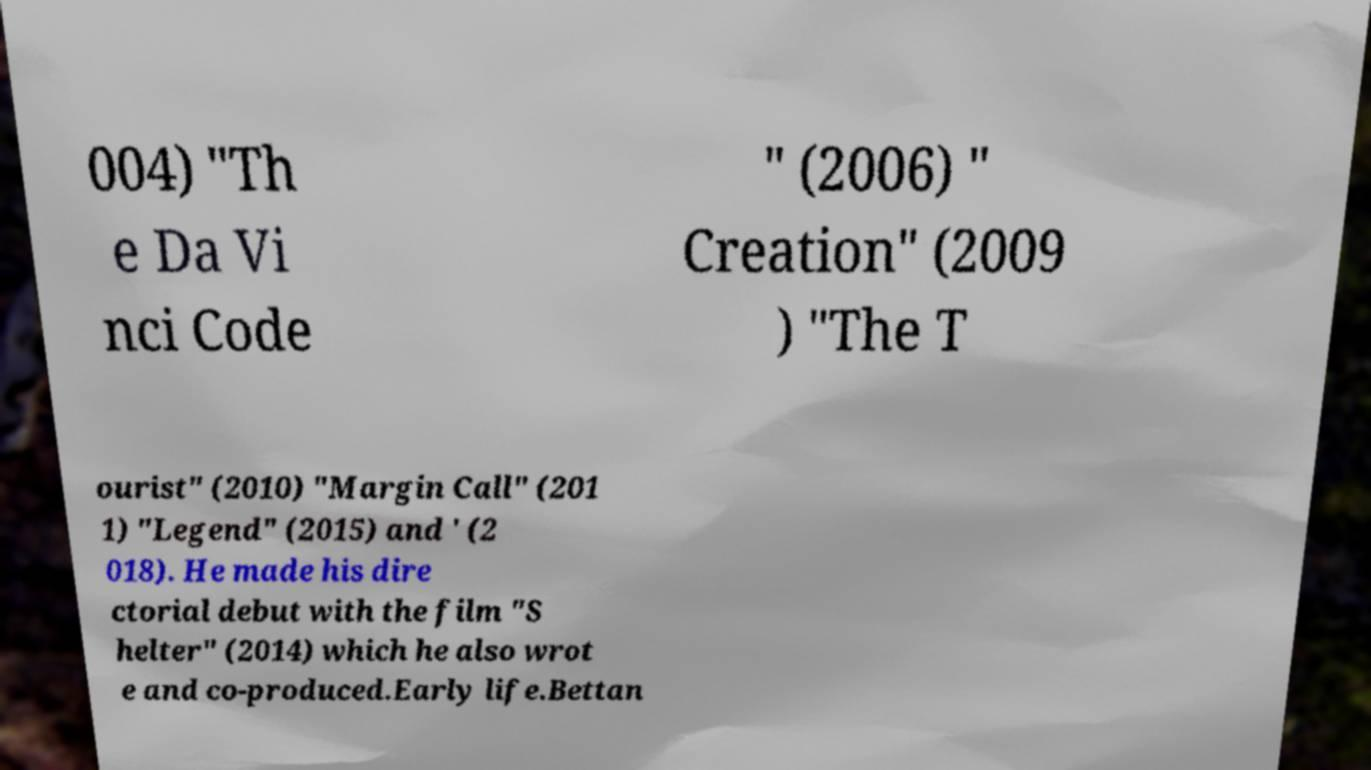Can you accurately transcribe the text from the provided image for me? 004) "Th e Da Vi nci Code " (2006) " Creation" (2009 ) "The T ourist" (2010) "Margin Call" (201 1) "Legend" (2015) and ' (2 018). He made his dire ctorial debut with the film "S helter" (2014) which he also wrot e and co-produced.Early life.Bettan 